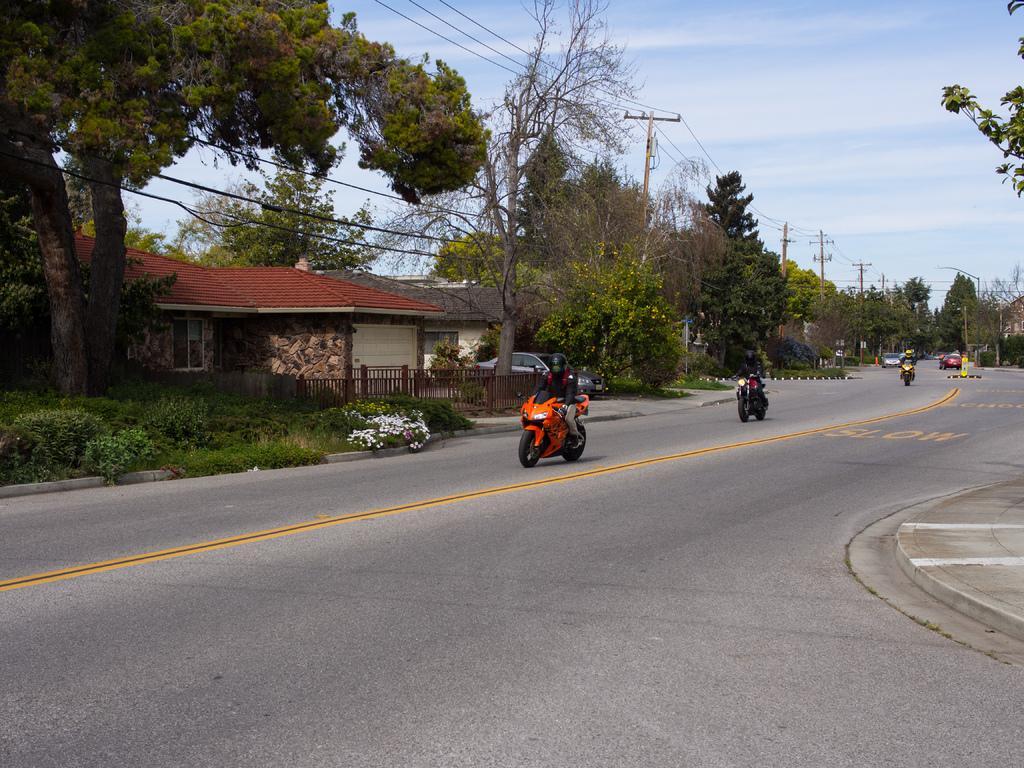Can you describe this image briefly? In this image we can see motor vehicles on the road, buildings, wooden grills, electric poles, electric cables, trees, shrubs, grass and sky with clouds in the background. 